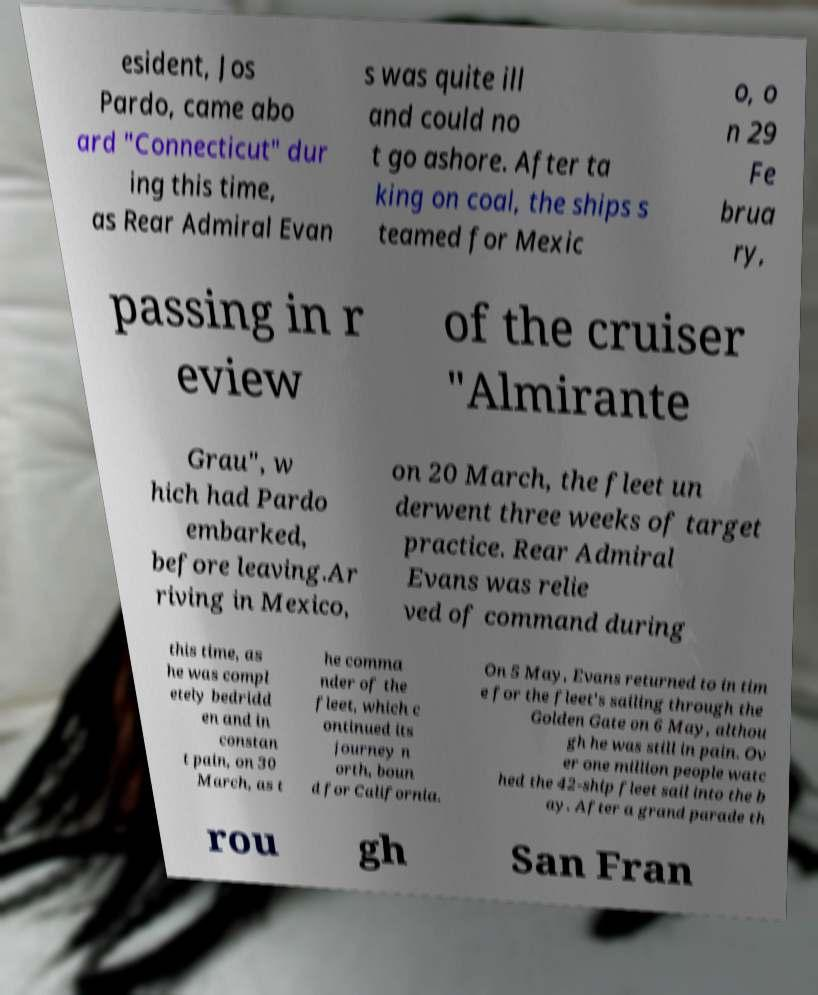There's text embedded in this image that I need extracted. Can you transcribe it verbatim? esident, Jos Pardo, came abo ard "Connecticut" dur ing this time, as Rear Admiral Evan s was quite ill and could no t go ashore. After ta king on coal, the ships s teamed for Mexic o, o n 29 Fe brua ry, passing in r eview of the cruiser "Almirante Grau", w hich had Pardo embarked, before leaving.Ar riving in Mexico, on 20 March, the fleet un derwent three weeks of target practice. Rear Admiral Evans was relie ved of command during this time, as he was compl etely bedridd en and in constan t pain, on 30 March, as t he comma nder of the fleet, which c ontinued its journey n orth, boun d for California. On 5 May, Evans returned to in tim e for the fleet's sailing through the Golden Gate on 6 May, althou gh he was still in pain. Ov er one million people watc hed the 42-ship fleet sail into the b ay. After a grand parade th rou gh San Fran 